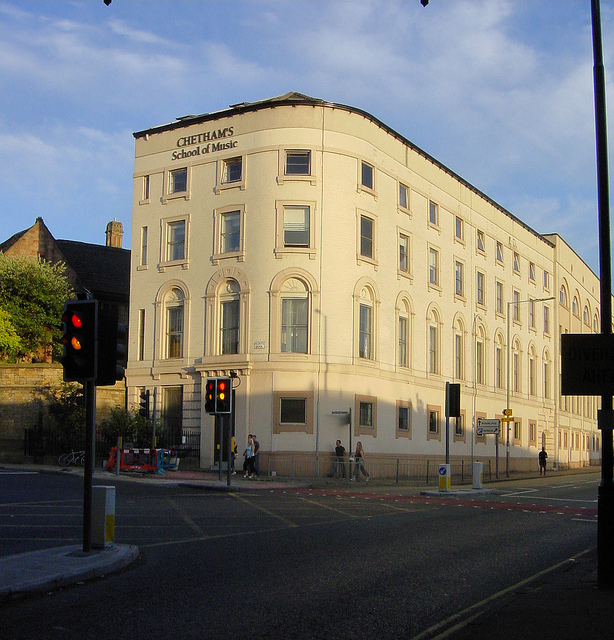<image>What was the sexual orientation of the person that designed parking area of this building? The sexual orientation of the person who designed the parking area of this building is unknown. What are the words on the building? I am not sure. It can be seen as "cheetham's school of music", "chetham's school of music", "chethams school", or "school of music". What was the sexual orientation of the person that designed parking area of this building? It is unknown what was the sexual orientation of the person that designed the parking area of this building. What are the words on the building? I don't know what are the words on the building. It can be seen "Cheetham's School of Music" or "Chethams School of Music". 